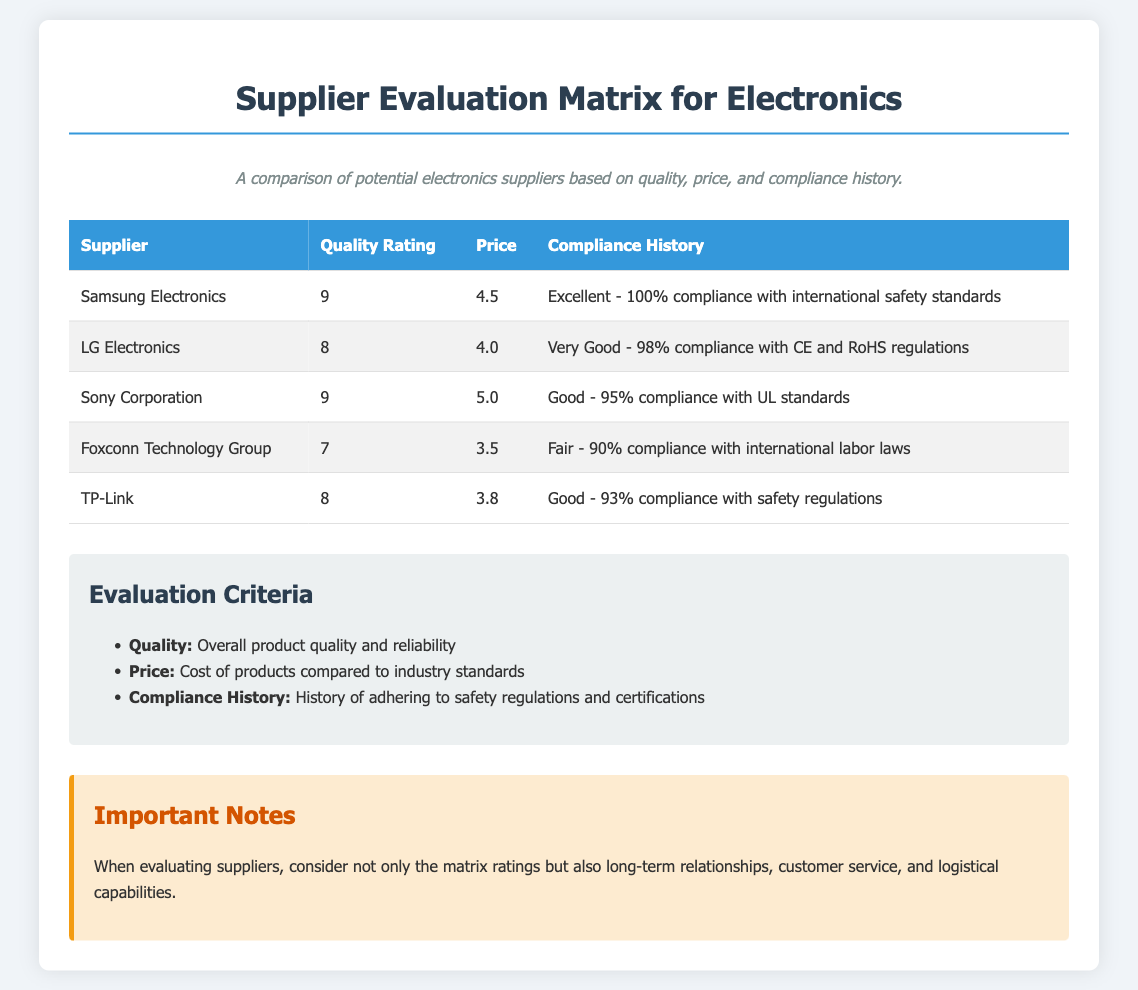What is the quality rating for Samsung Electronics? The quality rating for Samsung Electronics is listed in the table under "Quality Rating."
Answer: 9 Which supplier has the highest price? The highest price can be found by comparing the prices listed in the table; Sony Corporation has the highest price.
Answer: 5.0 What is the compliance history of Foxconn Technology Group? The compliance history is detailed in the table, specifically mentioning their adherence to international labor laws.
Answer: Fair - 90% compliance with international labor laws How many suppliers have a quality rating of 8 or higher? By examining the quality ratings in the table, I can count the number of suppliers with ratings of 8 or more.
Answer: 4 What is the average price of all suppliers listed? The average price is calculated by summing all prices and dividing by the number of suppliers.
Answer: 4.16 Which supplier has the lowest quality rating? The lowest quality rating is identified by reviewing the quality ratings for each supplier.
Answer: 7 What criteria is used to evaluate the suppliers? The evaluation criteria are listed under the "Evaluation Criteria" section.
Answer: Quality, Price, Compliance History What is mentioned regarding the evaluation of suppliers? The important notes provide additional context on evaluating suppliers beyond the ratings.
Answer: Consider long-term relationships, customer service, and logistical capabilities 